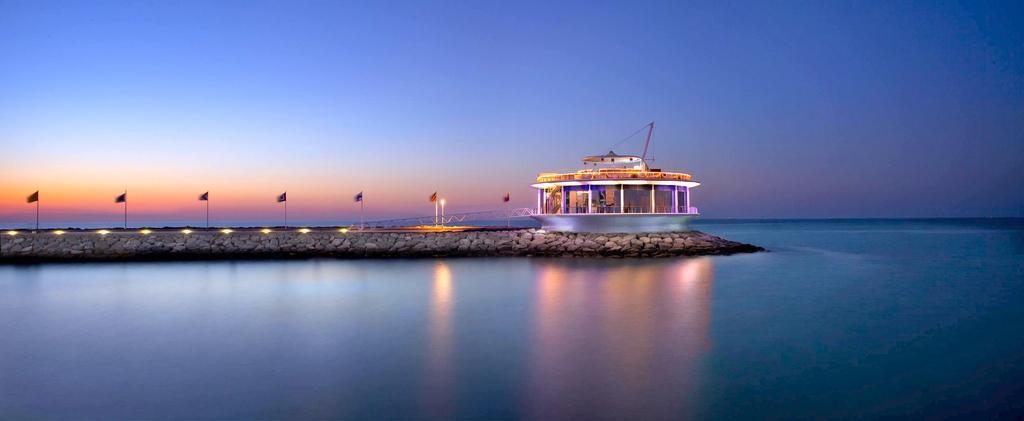Can you describe this image briefly? In this picture I can see the water and in the middle of this picture, I can see the path on which there are few lights, flags and a building. In the background I can see the sky. 